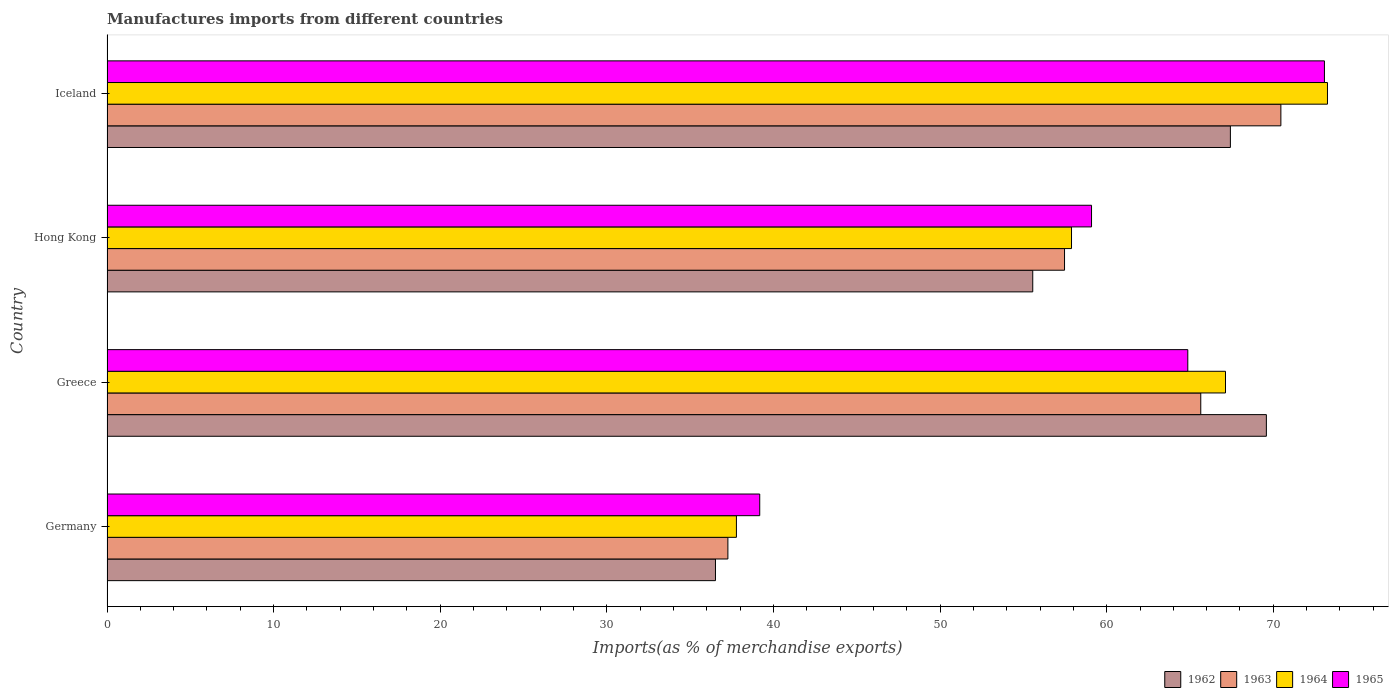How many different coloured bars are there?
Make the answer very short. 4. How many groups of bars are there?
Provide a succinct answer. 4. Are the number of bars per tick equal to the number of legend labels?
Keep it short and to the point. Yes. In how many cases, is the number of bars for a given country not equal to the number of legend labels?
Provide a succinct answer. 0. What is the percentage of imports to different countries in 1965 in Germany?
Provide a succinct answer. 39.18. Across all countries, what is the maximum percentage of imports to different countries in 1963?
Offer a terse response. 70.45. Across all countries, what is the minimum percentage of imports to different countries in 1962?
Your answer should be compact. 36.52. In which country was the percentage of imports to different countries in 1965 maximum?
Offer a terse response. Iceland. In which country was the percentage of imports to different countries in 1965 minimum?
Your response must be concise. Germany. What is the total percentage of imports to different countries in 1964 in the graph?
Your response must be concise. 236.05. What is the difference between the percentage of imports to different countries in 1963 in Hong Kong and that in Iceland?
Give a very brief answer. -12.98. What is the difference between the percentage of imports to different countries in 1964 in Greece and the percentage of imports to different countries in 1963 in Germany?
Ensure brevity in your answer.  29.87. What is the average percentage of imports to different countries in 1963 per country?
Provide a short and direct response. 57.71. What is the difference between the percentage of imports to different countries in 1965 and percentage of imports to different countries in 1964 in Iceland?
Provide a succinct answer. -0.18. What is the ratio of the percentage of imports to different countries in 1962 in Greece to that in Hong Kong?
Provide a succinct answer. 1.25. Is the difference between the percentage of imports to different countries in 1965 in Greece and Hong Kong greater than the difference between the percentage of imports to different countries in 1964 in Greece and Hong Kong?
Your response must be concise. No. What is the difference between the highest and the second highest percentage of imports to different countries in 1963?
Give a very brief answer. 4.81. What is the difference between the highest and the lowest percentage of imports to different countries in 1965?
Provide a short and direct response. 33.89. In how many countries, is the percentage of imports to different countries in 1965 greater than the average percentage of imports to different countries in 1965 taken over all countries?
Offer a terse response. 3. Is it the case that in every country, the sum of the percentage of imports to different countries in 1963 and percentage of imports to different countries in 1964 is greater than the sum of percentage of imports to different countries in 1965 and percentage of imports to different countries in 1962?
Offer a terse response. No. What does the 3rd bar from the top in Greece represents?
Your answer should be compact. 1963. What does the 3rd bar from the bottom in Iceland represents?
Your response must be concise. 1964. Is it the case that in every country, the sum of the percentage of imports to different countries in 1965 and percentage of imports to different countries in 1964 is greater than the percentage of imports to different countries in 1962?
Offer a very short reply. Yes. How many bars are there?
Provide a succinct answer. 16. Are all the bars in the graph horizontal?
Your answer should be very brief. Yes. How many countries are there in the graph?
Make the answer very short. 4. Does the graph contain any zero values?
Make the answer very short. No. Does the graph contain grids?
Ensure brevity in your answer.  No. What is the title of the graph?
Keep it short and to the point. Manufactures imports from different countries. What is the label or title of the X-axis?
Keep it short and to the point. Imports(as % of merchandise exports). What is the label or title of the Y-axis?
Offer a terse response. Country. What is the Imports(as % of merchandise exports) of 1962 in Germany?
Ensure brevity in your answer.  36.52. What is the Imports(as % of merchandise exports) of 1963 in Germany?
Give a very brief answer. 37.26. What is the Imports(as % of merchandise exports) in 1964 in Germany?
Ensure brevity in your answer.  37.78. What is the Imports(as % of merchandise exports) in 1965 in Germany?
Your answer should be very brief. 39.18. What is the Imports(as % of merchandise exports) in 1962 in Greece?
Offer a terse response. 69.58. What is the Imports(as % of merchandise exports) in 1963 in Greece?
Your answer should be very brief. 65.65. What is the Imports(as % of merchandise exports) of 1964 in Greece?
Make the answer very short. 67.13. What is the Imports(as % of merchandise exports) of 1965 in Greece?
Your response must be concise. 64.87. What is the Imports(as % of merchandise exports) in 1962 in Hong Kong?
Keep it short and to the point. 55.56. What is the Imports(as % of merchandise exports) in 1963 in Hong Kong?
Ensure brevity in your answer.  57.47. What is the Imports(as % of merchandise exports) in 1964 in Hong Kong?
Provide a succinct answer. 57.89. What is the Imports(as % of merchandise exports) of 1965 in Hong Kong?
Your answer should be very brief. 59.09. What is the Imports(as % of merchandise exports) in 1962 in Iceland?
Make the answer very short. 67.42. What is the Imports(as % of merchandise exports) of 1963 in Iceland?
Your response must be concise. 70.45. What is the Imports(as % of merchandise exports) in 1964 in Iceland?
Your answer should be very brief. 73.25. What is the Imports(as % of merchandise exports) in 1965 in Iceland?
Give a very brief answer. 73.07. Across all countries, what is the maximum Imports(as % of merchandise exports) of 1962?
Provide a short and direct response. 69.58. Across all countries, what is the maximum Imports(as % of merchandise exports) of 1963?
Offer a terse response. 70.45. Across all countries, what is the maximum Imports(as % of merchandise exports) in 1964?
Make the answer very short. 73.25. Across all countries, what is the maximum Imports(as % of merchandise exports) in 1965?
Provide a succinct answer. 73.07. Across all countries, what is the minimum Imports(as % of merchandise exports) of 1962?
Offer a very short reply. 36.52. Across all countries, what is the minimum Imports(as % of merchandise exports) in 1963?
Make the answer very short. 37.26. Across all countries, what is the minimum Imports(as % of merchandise exports) in 1964?
Provide a succinct answer. 37.78. Across all countries, what is the minimum Imports(as % of merchandise exports) of 1965?
Your answer should be compact. 39.18. What is the total Imports(as % of merchandise exports) of 1962 in the graph?
Give a very brief answer. 229.09. What is the total Imports(as % of merchandise exports) of 1963 in the graph?
Your answer should be compact. 230.83. What is the total Imports(as % of merchandise exports) of 1964 in the graph?
Your answer should be very brief. 236.05. What is the total Imports(as % of merchandise exports) of 1965 in the graph?
Give a very brief answer. 236.2. What is the difference between the Imports(as % of merchandise exports) in 1962 in Germany and that in Greece?
Make the answer very short. -33.06. What is the difference between the Imports(as % of merchandise exports) in 1963 in Germany and that in Greece?
Offer a very short reply. -28.38. What is the difference between the Imports(as % of merchandise exports) in 1964 in Germany and that in Greece?
Give a very brief answer. -29.35. What is the difference between the Imports(as % of merchandise exports) in 1965 in Germany and that in Greece?
Provide a succinct answer. -25.69. What is the difference between the Imports(as % of merchandise exports) of 1962 in Germany and that in Hong Kong?
Provide a succinct answer. -19.04. What is the difference between the Imports(as % of merchandise exports) in 1963 in Germany and that in Hong Kong?
Provide a succinct answer. -20.2. What is the difference between the Imports(as % of merchandise exports) of 1964 in Germany and that in Hong Kong?
Offer a terse response. -20.11. What is the difference between the Imports(as % of merchandise exports) in 1965 in Germany and that in Hong Kong?
Your response must be concise. -19.91. What is the difference between the Imports(as % of merchandise exports) in 1962 in Germany and that in Iceland?
Provide a short and direct response. -30.9. What is the difference between the Imports(as % of merchandise exports) in 1963 in Germany and that in Iceland?
Keep it short and to the point. -33.19. What is the difference between the Imports(as % of merchandise exports) in 1964 in Germany and that in Iceland?
Keep it short and to the point. -35.47. What is the difference between the Imports(as % of merchandise exports) of 1965 in Germany and that in Iceland?
Provide a succinct answer. -33.89. What is the difference between the Imports(as % of merchandise exports) in 1962 in Greece and that in Hong Kong?
Your answer should be very brief. 14.02. What is the difference between the Imports(as % of merchandise exports) in 1963 in Greece and that in Hong Kong?
Provide a short and direct response. 8.18. What is the difference between the Imports(as % of merchandise exports) of 1964 in Greece and that in Hong Kong?
Offer a terse response. 9.24. What is the difference between the Imports(as % of merchandise exports) of 1965 in Greece and that in Hong Kong?
Your answer should be very brief. 5.78. What is the difference between the Imports(as % of merchandise exports) in 1962 in Greece and that in Iceland?
Provide a succinct answer. 2.16. What is the difference between the Imports(as % of merchandise exports) in 1963 in Greece and that in Iceland?
Give a very brief answer. -4.81. What is the difference between the Imports(as % of merchandise exports) in 1964 in Greece and that in Iceland?
Your answer should be very brief. -6.12. What is the difference between the Imports(as % of merchandise exports) of 1965 in Greece and that in Iceland?
Provide a short and direct response. -8.2. What is the difference between the Imports(as % of merchandise exports) of 1962 in Hong Kong and that in Iceland?
Give a very brief answer. -11.86. What is the difference between the Imports(as % of merchandise exports) of 1963 in Hong Kong and that in Iceland?
Provide a succinct answer. -12.98. What is the difference between the Imports(as % of merchandise exports) in 1964 in Hong Kong and that in Iceland?
Keep it short and to the point. -15.36. What is the difference between the Imports(as % of merchandise exports) of 1965 in Hong Kong and that in Iceland?
Ensure brevity in your answer.  -13.98. What is the difference between the Imports(as % of merchandise exports) in 1962 in Germany and the Imports(as % of merchandise exports) in 1963 in Greece?
Offer a very short reply. -29.13. What is the difference between the Imports(as % of merchandise exports) in 1962 in Germany and the Imports(as % of merchandise exports) in 1964 in Greece?
Make the answer very short. -30.61. What is the difference between the Imports(as % of merchandise exports) of 1962 in Germany and the Imports(as % of merchandise exports) of 1965 in Greece?
Keep it short and to the point. -28.35. What is the difference between the Imports(as % of merchandise exports) in 1963 in Germany and the Imports(as % of merchandise exports) in 1964 in Greece?
Give a very brief answer. -29.87. What is the difference between the Imports(as % of merchandise exports) in 1963 in Germany and the Imports(as % of merchandise exports) in 1965 in Greece?
Give a very brief answer. -27.6. What is the difference between the Imports(as % of merchandise exports) in 1964 in Germany and the Imports(as % of merchandise exports) in 1965 in Greece?
Provide a short and direct response. -27.09. What is the difference between the Imports(as % of merchandise exports) in 1962 in Germany and the Imports(as % of merchandise exports) in 1963 in Hong Kong?
Keep it short and to the point. -20.95. What is the difference between the Imports(as % of merchandise exports) in 1962 in Germany and the Imports(as % of merchandise exports) in 1964 in Hong Kong?
Provide a succinct answer. -21.37. What is the difference between the Imports(as % of merchandise exports) in 1962 in Germany and the Imports(as % of merchandise exports) in 1965 in Hong Kong?
Provide a succinct answer. -22.57. What is the difference between the Imports(as % of merchandise exports) of 1963 in Germany and the Imports(as % of merchandise exports) of 1964 in Hong Kong?
Offer a very short reply. -20.62. What is the difference between the Imports(as % of merchandise exports) in 1963 in Germany and the Imports(as % of merchandise exports) in 1965 in Hong Kong?
Make the answer very short. -21.83. What is the difference between the Imports(as % of merchandise exports) in 1964 in Germany and the Imports(as % of merchandise exports) in 1965 in Hong Kong?
Your response must be concise. -21.31. What is the difference between the Imports(as % of merchandise exports) of 1962 in Germany and the Imports(as % of merchandise exports) of 1963 in Iceland?
Your response must be concise. -33.93. What is the difference between the Imports(as % of merchandise exports) in 1962 in Germany and the Imports(as % of merchandise exports) in 1964 in Iceland?
Offer a terse response. -36.73. What is the difference between the Imports(as % of merchandise exports) of 1962 in Germany and the Imports(as % of merchandise exports) of 1965 in Iceland?
Keep it short and to the point. -36.55. What is the difference between the Imports(as % of merchandise exports) in 1963 in Germany and the Imports(as % of merchandise exports) in 1964 in Iceland?
Offer a terse response. -35.99. What is the difference between the Imports(as % of merchandise exports) in 1963 in Germany and the Imports(as % of merchandise exports) in 1965 in Iceland?
Provide a short and direct response. -35.8. What is the difference between the Imports(as % of merchandise exports) in 1964 in Germany and the Imports(as % of merchandise exports) in 1965 in Iceland?
Your response must be concise. -35.29. What is the difference between the Imports(as % of merchandise exports) of 1962 in Greece and the Imports(as % of merchandise exports) of 1963 in Hong Kong?
Your answer should be compact. 12.12. What is the difference between the Imports(as % of merchandise exports) in 1962 in Greece and the Imports(as % of merchandise exports) in 1964 in Hong Kong?
Provide a short and direct response. 11.7. What is the difference between the Imports(as % of merchandise exports) of 1962 in Greece and the Imports(as % of merchandise exports) of 1965 in Hong Kong?
Offer a terse response. 10.49. What is the difference between the Imports(as % of merchandise exports) of 1963 in Greece and the Imports(as % of merchandise exports) of 1964 in Hong Kong?
Provide a succinct answer. 7.76. What is the difference between the Imports(as % of merchandise exports) in 1963 in Greece and the Imports(as % of merchandise exports) in 1965 in Hong Kong?
Make the answer very short. 6.56. What is the difference between the Imports(as % of merchandise exports) in 1964 in Greece and the Imports(as % of merchandise exports) in 1965 in Hong Kong?
Provide a short and direct response. 8.04. What is the difference between the Imports(as % of merchandise exports) of 1962 in Greece and the Imports(as % of merchandise exports) of 1963 in Iceland?
Provide a succinct answer. -0.87. What is the difference between the Imports(as % of merchandise exports) of 1962 in Greece and the Imports(as % of merchandise exports) of 1964 in Iceland?
Offer a very short reply. -3.67. What is the difference between the Imports(as % of merchandise exports) of 1962 in Greece and the Imports(as % of merchandise exports) of 1965 in Iceland?
Provide a short and direct response. -3.48. What is the difference between the Imports(as % of merchandise exports) in 1963 in Greece and the Imports(as % of merchandise exports) in 1964 in Iceland?
Your response must be concise. -7.6. What is the difference between the Imports(as % of merchandise exports) of 1963 in Greece and the Imports(as % of merchandise exports) of 1965 in Iceland?
Provide a succinct answer. -7.42. What is the difference between the Imports(as % of merchandise exports) in 1964 in Greece and the Imports(as % of merchandise exports) in 1965 in Iceland?
Your answer should be very brief. -5.94. What is the difference between the Imports(as % of merchandise exports) of 1962 in Hong Kong and the Imports(as % of merchandise exports) of 1963 in Iceland?
Your response must be concise. -14.89. What is the difference between the Imports(as % of merchandise exports) in 1962 in Hong Kong and the Imports(as % of merchandise exports) in 1964 in Iceland?
Ensure brevity in your answer.  -17.69. What is the difference between the Imports(as % of merchandise exports) in 1962 in Hong Kong and the Imports(as % of merchandise exports) in 1965 in Iceland?
Provide a short and direct response. -17.51. What is the difference between the Imports(as % of merchandise exports) in 1963 in Hong Kong and the Imports(as % of merchandise exports) in 1964 in Iceland?
Your response must be concise. -15.78. What is the difference between the Imports(as % of merchandise exports) in 1963 in Hong Kong and the Imports(as % of merchandise exports) in 1965 in Iceland?
Keep it short and to the point. -15.6. What is the difference between the Imports(as % of merchandise exports) of 1964 in Hong Kong and the Imports(as % of merchandise exports) of 1965 in Iceland?
Your answer should be compact. -15.18. What is the average Imports(as % of merchandise exports) in 1962 per country?
Give a very brief answer. 57.27. What is the average Imports(as % of merchandise exports) in 1963 per country?
Offer a very short reply. 57.71. What is the average Imports(as % of merchandise exports) in 1964 per country?
Offer a very short reply. 59.01. What is the average Imports(as % of merchandise exports) of 1965 per country?
Ensure brevity in your answer.  59.05. What is the difference between the Imports(as % of merchandise exports) of 1962 and Imports(as % of merchandise exports) of 1963 in Germany?
Keep it short and to the point. -0.75. What is the difference between the Imports(as % of merchandise exports) in 1962 and Imports(as % of merchandise exports) in 1964 in Germany?
Your answer should be very brief. -1.26. What is the difference between the Imports(as % of merchandise exports) of 1962 and Imports(as % of merchandise exports) of 1965 in Germany?
Give a very brief answer. -2.66. What is the difference between the Imports(as % of merchandise exports) in 1963 and Imports(as % of merchandise exports) in 1964 in Germany?
Provide a succinct answer. -0.51. What is the difference between the Imports(as % of merchandise exports) of 1963 and Imports(as % of merchandise exports) of 1965 in Germany?
Provide a succinct answer. -1.91. What is the difference between the Imports(as % of merchandise exports) in 1964 and Imports(as % of merchandise exports) in 1965 in Germany?
Give a very brief answer. -1.4. What is the difference between the Imports(as % of merchandise exports) in 1962 and Imports(as % of merchandise exports) in 1963 in Greece?
Ensure brevity in your answer.  3.94. What is the difference between the Imports(as % of merchandise exports) of 1962 and Imports(as % of merchandise exports) of 1964 in Greece?
Keep it short and to the point. 2.45. What is the difference between the Imports(as % of merchandise exports) in 1962 and Imports(as % of merchandise exports) in 1965 in Greece?
Keep it short and to the point. 4.72. What is the difference between the Imports(as % of merchandise exports) of 1963 and Imports(as % of merchandise exports) of 1964 in Greece?
Your response must be concise. -1.48. What is the difference between the Imports(as % of merchandise exports) in 1963 and Imports(as % of merchandise exports) in 1965 in Greece?
Your answer should be compact. 0.78. What is the difference between the Imports(as % of merchandise exports) of 1964 and Imports(as % of merchandise exports) of 1965 in Greece?
Provide a succinct answer. 2.26. What is the difference between the Imports(as % of merchandise exports) of 1962 and Imports(as % of merchandise exports) of 1963 in Hong Kong?
Your answer should be very brief. -1.91. What is the difference between the Imports(as % of merchandise exports) of 1962 and Imports(as % of merchandise exports) of 1964 in Hong Kong?
Offer a very short reply. -2.33. What is the difference between the Imports(as % of merchandise exports) of 1962 and Imports(as % of merchandise exports) of 1965 in Hong Kong?
Provide a succinct answer. -3.53. What is the difference between the Imports(as % of merchandise exports) in 1963 and Imports(as % of merchandise exports) in 1964 in Hong Kong?
Ensure brevity in your answer.  -0.42. What is the difference between the Imports(as % of merchandise exports) in 1963 and Imports(as % of merchandise exports) in 1965 in Hong Kong?
Provide a short and direct response. -1.62. What is the difference between the Imports(as % of merchandise exports) in 1964 and Imports(as % of merchandise exports) in 1965 in Hong Kong?
Ensure brevity in your answer.  -1.2. What is the difference between the Imports(as % of merchandise exports) of 1962 and Imports(as % of merchandise exports) of 1963 in Iceland?
Provide a short and direct response. -3.03. What is the difference between the Imports(as % of merchandise exports) in 1962 and Imports(as % of merchandise exports) in 1964 in Iceland?
Your answer should be compact. -5.83. What is the difference between the Imports(as % of merchandise exports) in 1962 and Imports(as % of merchandise exports) in 1965 in Iceland?
Provide a short and direct response. -5.64. What is the difference between the Imports(as % of merchandise exports) of 1963 and Imports(as % of merchandise exports) of 1964 in Iceland?
Your answer should be compact. -2.8. What is the difference between the Imports(as % of merchandise exports) in 1963 and Imports(as % of merchandise exports) in 1965 in Iceland?
Give a very brief answer. -2.61. What is the difference between the Imports(as % of merchandise exports) of 1964 and Imports(as % of merchandise exports) of 1965 in Iceland?
Your answer should be compact. 0.18. What is the ratio of the Imports(as % of merchandise exports) in 1962 in Germany to that in Greece?
Provide a succinct answer. 0.52. What is the ratio of the Imports(as % of merchandise exports) of 1963 in Germany to that in Greece?
Provide a short and direct response. 0.57. What is the ratio of the Imports(as % of merchandise exports) in 1964 in Germany to that in Greece?
Offer a very short reply. 0.56. What is the ratio of the Imports(as % of merchandise exports) in 1965 in Germany to that in Greece?
Provide a succinct answer. 0.6. What is the ratio of the Imports(as % of merchandise exports) of 1962 in Germany to that in Hong Kong?
Your answer should be very brief. 0.66. What is the ratio of the Imports(as % of merchandise exports) of 1963 in Germany to that in Hong Kong?
Your response must be concise. 0.65. What is the ratio of the Imports(as % of merchandise exports) in 1964 in Germany to that in Hong Kong?
Offer a very short reply. 0.65. What is the ratio of the Imports(as % of merchandise exports) in 1965 in Germany to that in Hong Kong?
Make the answer very short. 0.66. What is the ratio of the Imports(as % of merchandise exports) of 1962 in Germany to that in Iceland?
Your answer should be compact. 0.54. What is the ratio of the Imports(as % of merchandise exports) of 1963 in Germany to that in Iceland?
Your response must be concise. 0.53. What is the ratio of the Imports(as % of merchandise exports) of 1964 in Germany to that in Iceland?
Keep it short and to the point. 0.52. What is the ratio of the Imports(as % of merchandise exports) in 1965 in Germany to that in Iceland?
Give a very brief answer. 0.54. What is the ratio of the Imports(as % of merchandise exports) of 1962 in Greece to that in Hong Kong?
Ensure brevity in your answer.  1.25. What is the ratio of the Imports(as % of merchandise exports) of 1963 in Greece to that in Hong Kong?
Make the answer very short. 1.14. What is the ratio of the Imports(as % of merchandise exports) of 1964 in Greece to that in Hong Kong?
Your answer should be compact. 1.16. What is the ratio of the Imports(as % of merchandise exports) of 1965 in Greece to that in Hong Kong?
Keep it short and to the point. 1.1. What is the ratio of the Imports(as % of merchandise exports) of 1962 in Greece to that in Iceland?
Give a very brief answer. 1.03. What is the ratio of the Imports(as % of merchandise exports) of 1963 in Greece to that in Iceland?
Your answer should be compact. 0.93. What is the ratio of the Imports(as % of merchandise exports) in 1964 in Greece to that in Iceland?
Your response must be concise. 0.92. What is the ratio of the Imports(as % of merchandise exports) in 1965 in Greece to that in Iceland?
Provide a short and direct response. 0.89. What is the ratio of the Imports(as % of merchandise exports) in 1962 in Hong Kong to that in Iceland?
Your response must be concise. 0.82. What is the ratio of the Imports(as % of merchandise exports) in 1963 in Hong Kong to that in Iceland?
Your response must be concise. 0.82. What is the ratio of the Imports(as % of merchandise exports) in 1964 in Hong Kong to that in Iceland?
Make the answer very short. 0.79. What is the ratio of the Imports(as % of merchandise exports) of 1965 in Hong Kong to that in Iceland?
Keep it short and to the point. 0.81. What is the difference between the highest and the second highest Imports(as % of merchandise exports) in 1962?
Give a very brief answer. 2.16. What is the difference between the highest and the second highest Imports(as % of merchandise exports) of 1963?
Make the answer very short. 4.81. What is the difference between the highest and the second highest Imports(as % of merchandise exports) of 1964?
Your answer should be very brief. 6.12. What is the difference between the highest and the second highest Imports(as % of merchandise exports) of 1965?
Ensure brevity in your answer.  8.2. What is the difference between the highest and the lowest Imports(as % of merchandise exports) in 1962?
Make the answer very short. 33.06. What is the difference between the highest and the lowest Imports(as % of merchandise exports) of 1963?
Your answer should be very brief. 33.19. What is the difference between the highest and the lowest Imports(as % of merchandise exports) in 1964?
Your response must be concise. 35.47. What is the difference between the highest and the lowest Imports(as % of merchandise exports) of 1965?
Your answer should be very brief. 33.89. 